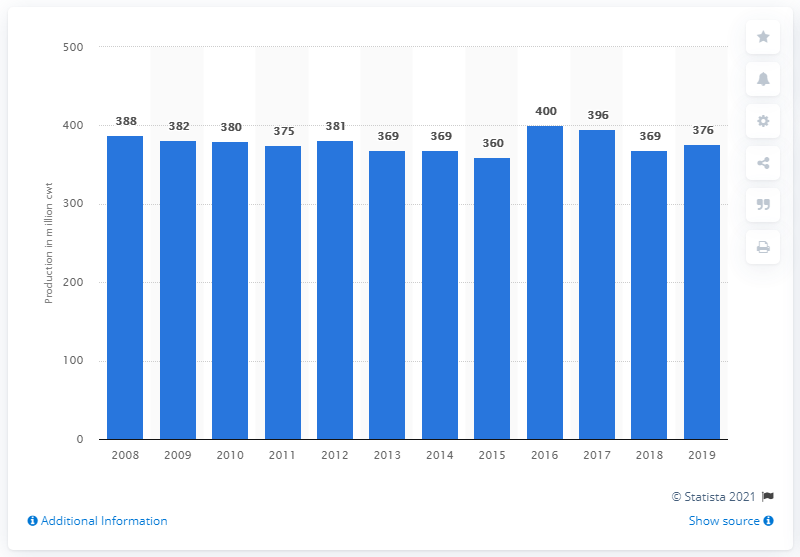Give some essential details in this illustration. I'm sorry, I'm not sure what you are asking for. Could you please provide more context or clarify your question? 